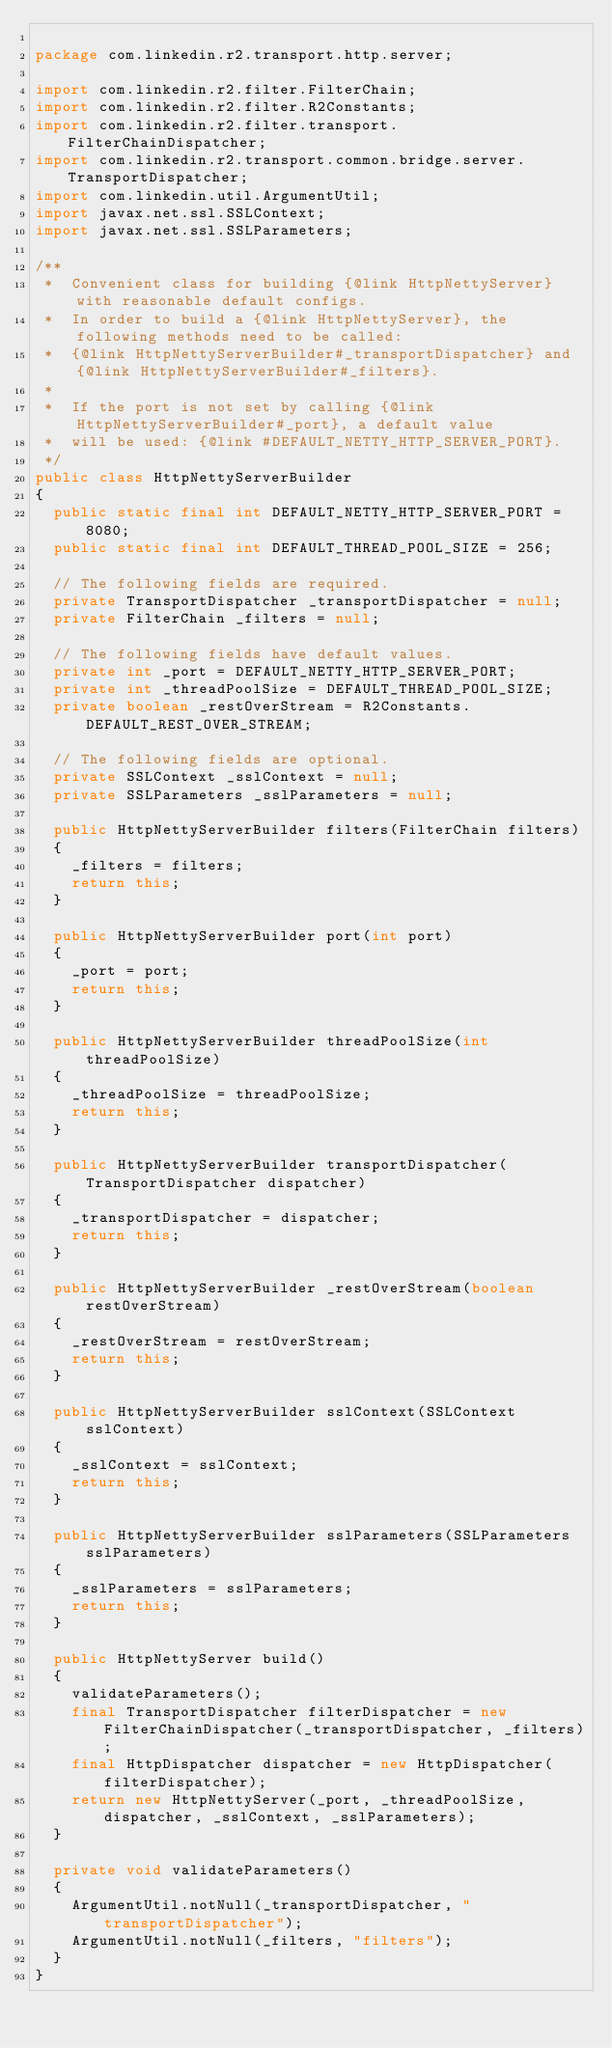Convert code to text. <code><loc_0><loc_0><loc_500><loc_500><_Java_>
package com.linkedin.r2.transport.http.server;

import com.linkedin.r2.filter.FilterChain;
import com.linkedin.r2.filter.R2Constants;
import com.linkedin.r2.filter.transport.FilterChainDispatcher;
import com.linkedin.r2.transport.common.bridge.server.TransportDispatcher;
import com.linkedin.util.ArgumentUtil;
import javax.net.ssl.SSLContext;
import javax.net.ssl.SSLParameters;

/**
 *  Convenient class for building {@link HttpNettyServer} with reasonable default configs.
 *  In order to build a {@link HttpNettyServer}, the following methods need to be called:
 *  {@link HttpNettyServerBuilder#_transportDispatcher} and {@link HttpNettyServerBuilder#_filters}.
 *
 *  If the port is not set by calling {@link HttpNettyServerBuilder#_port}, a default value
 *  will be used: {@link #DEFAULT_NETTY_HTTP_SERVER_PORT}.
 */
public class HttpNettyServerBuilder
{
  public static final int DEFAULT_NETTY_HTTP_SERVER_PORT = 8080;
  public static final int DEFAULT_THREAD_POOL_SIZE = 256;

  // The following fields are required.
  private TransportDispatcher _transportDispatcher = null;
  private FilterChain _filters = null;

  // The following fields have default values.
  private int _port = DEFAULT_NETTY_HTTP_SERVER_PORT;
  private int _threadPoolSize = DEFAULT_THREAD_POOL_SIZE;
  private boolean _restOverStream = R2Constants.DEFAULT_REST_OVER_STREAM;

  // The following fields are optional.
  private SSLContext _sslContext = null;
  private SSLParameters _sslParameters = null;

  public HttpNettyServerBuilder filters(FilterChain filters)
  {
    _filters = filters;
    return this;
  }

  public HttpNettyServerBuilder port(int port)
  {
    _port = port;
    return this;
  }

  public HttpNettyServerBuilder threadPoolSize(int threadPoolSize)
  {
    _threadPoolSize = threadPoolSize;
    return this;
  }

  public HttpNettyServerBuilder transportDispatcher(TransportDispatcher dispatcher)
  {
    _transportDispatcher = dispatcher;
    return this;
  }

  public HttpNettyServerBuilder _restOverStream(boolean restOverStream)
  {
    _restOverStream = restOverStream;
    return this;
  }

  public HttpNettyServerBuilder sslContext(SSLContext sslContext)
  {
    _sslContext = sslContext;
    return this;
  }

  public HttpNettyServerBuilder sslParameters(SSLParameters sslParameters)
  {
    _sslParameters = sslParameters;
    return this;
  }

  public HttpNettyServer build()
  {
    validateParameters();
    final TransportDispatcher filterDispatcher = new FilterChainDispatcher(_transportDispatcher, _filters);
    final HttpDispatcher dispatcher = new HttpDispatcher(filterDispatcher);
    return new HttpNettyServer(_port, _threadPoolSize, dispatcher, _sslContext, _sslParameters);
  }

  private void validateParameters()
  {
    ArgumentUtil.notNull(_transportDispatcher, "transportDispatcher");
    ArgumentUtil.notNull(_filters, "filters");
  }
}
</code> 